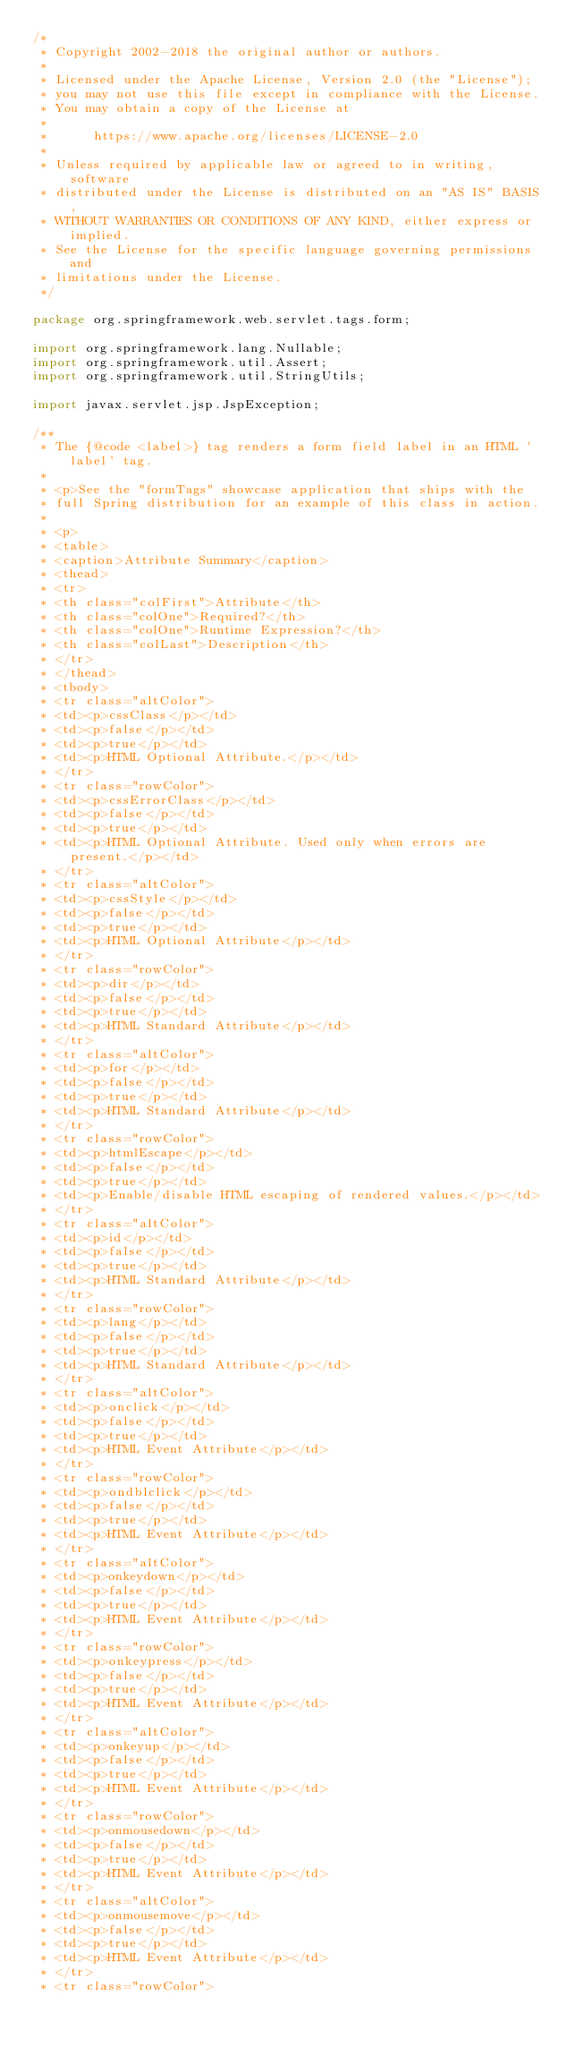Convert code to text. <code><loc_0><loc_0><loc_500><loc_500><_Java_>/*
 * Copyright 2002-2018 the original author or authors.
 *
 * Licensed under the Apache License, Version 2.0 (the "License");
 * you may not use this file except in compliance with the License.
 * You may obtain a copy of the License at
 *
 *      https://www.apache.org/licenses/LICENSE-2.0
 *
 * Unless required by applicable law or agreed to in writing, software
 * distributed under the License is distributed on an "AS IS" BASIS,
 * WITHOUT WARRANTIES OR CONDITIONS OF ANY KIND, either express or implied.
 * See the License for the specific language governing permissions and
 * limitations under the License.
 */

package org.springframework.web.servlet.tags.form;

import org.springframework.lang.Nullable;
import org.springframework.util.Assert;
import org.springframework.util.StringUtils;

import javax.servlet.jsp.JspException;

/**
 * The {@code <label>} tag renders a form field label in an HTML 'label' tag.
 *
 * <p>See the "formTags" showcase application that ships with the
 * full Spring distribution for an example of this class in action.
 *
 * <p>
 * <table>
 * <caption>Attribute Summary</caption>
 * <thead>
 * <tr>
 * <th class="colFirst">Attribute</th>
 * <th class="colOne">Required?</th>
 * <th class="colOne">Runtime Expression?</th>
 * <th class="colLast">Description</th>
 * </tr>
 * </thead>
 * <tbody>
 * <tr class="altColor">
 * <td><p>cssClass</p></td>
 * <td><p>false</p></td>
 * <td><p>true</p></td>
 * <td><p>HTML Optional Attribute.</p></td>
 * </tr>
 * <tr class="rowColor">
 * <td><p>cssErrorClass</p></td>
 * <td><p>false</p></td>
 * <td><p>true</p></td>
 * <td><p>HTML Optional Attribute. Used only when errors are present.</p></td>
 * </tr>
 * <tr class="altColor">
 * <td><p>cssStyle</p></td>
 * <td><p>false</p></td>
 * <td><p>true</p></td>
 * <td><p>HTML Optional Attribute</p></td>
 * </tr>
 * <tr class="rowColor">
 * <td><p>dir</p></td>
 * <td><p>false</p></td>
 * <td><p>true</p></td>
 * <td><p>HTML Standard Attribute</p></td>
 * </tr>
 * <tr class="altColor">
 * <td><p>for</p></td>
 * <td><p>false</p></td>
 * <td><p>true</p></td>
 * <td><p>HTML Standard Attribute</p></td>
 * </tr>
 * <tr class="rowColor">
 * <td><p>htmlEscape</p></td>
 * <td><p>false</p></td>
 * <td><p>true</p></td>
 * <td><p>Enable/disable HTML escaping of rendered values.</p></td>
 * </tr>
 * <tr class="altColor">
 * <td><p>id</p></td>
 * <td><p>false</p></td>
 * <td><p>true</p></td>
 * <td><p>HTML Standard Attribute</p></td>
 * </tr>
 * <tr class="rowColor">
 * <td><p>lang</p></td>
 * <td><p>false</p></td>
 * <td><p>true</p></td>
 * <td><p>HTML Standard Attribute</p></td>
 * </tr>
 * <tr class="altColor">
 * <td><p>onclick</p></td>
 * <td><p>false</p></td>
 * <td><p>true</p></td>
 * <td><p>HTML Event Attribute</p></td>
 * </tr>
 * <tr class="rowColor">
 * <td><p>ondblclick</p></td>
 * <td><p>false</p></td>
 * <td><p>true</p></td>
 * <td><p>HTML Event Attribute</p></td>
 * </tr>
 * <tr class="altColor">
 * <td><p>onkeydown</p></td>
 * <td><p>false</p></td>
 * <td><p>true</p></td>
 * <td><p>HTML Event Attribute</p></td>
 * </tr>
 * <tr class="rowColor">
 * <td><p>onkeypress</p></td>
 * <td><p>false</p></td>
 * <td><p>true</p></td>
 * <td><p>HTML Event Attribute</p></td>
 * </tr>
 * <tr class="altColor">
 * <td><p>onkeyup</p></td>
 * <td><p>false</p></td>
 * <td><p>true</p></td>
 * <td><p>HTML Event Attribute</p></td>
 * </tr>
 * <tr class="rowColor">
 * <td><p>onmousedown</p></td>
 * <td><p>false</p></td>
 * <td><p>true</p></td>
 * <td><p>HTML Event Attribute</p></td>
 * </tr>
 * <tr class="altColor">
 * <td><p>onmousemove</p></td>
 * <td><p>false</p></td>
 * <td><p>true</p></td>
 * <td><p>HTML Event Attribute</p></td>
 * </tr>
 * <tr class="rowColor"></code> 